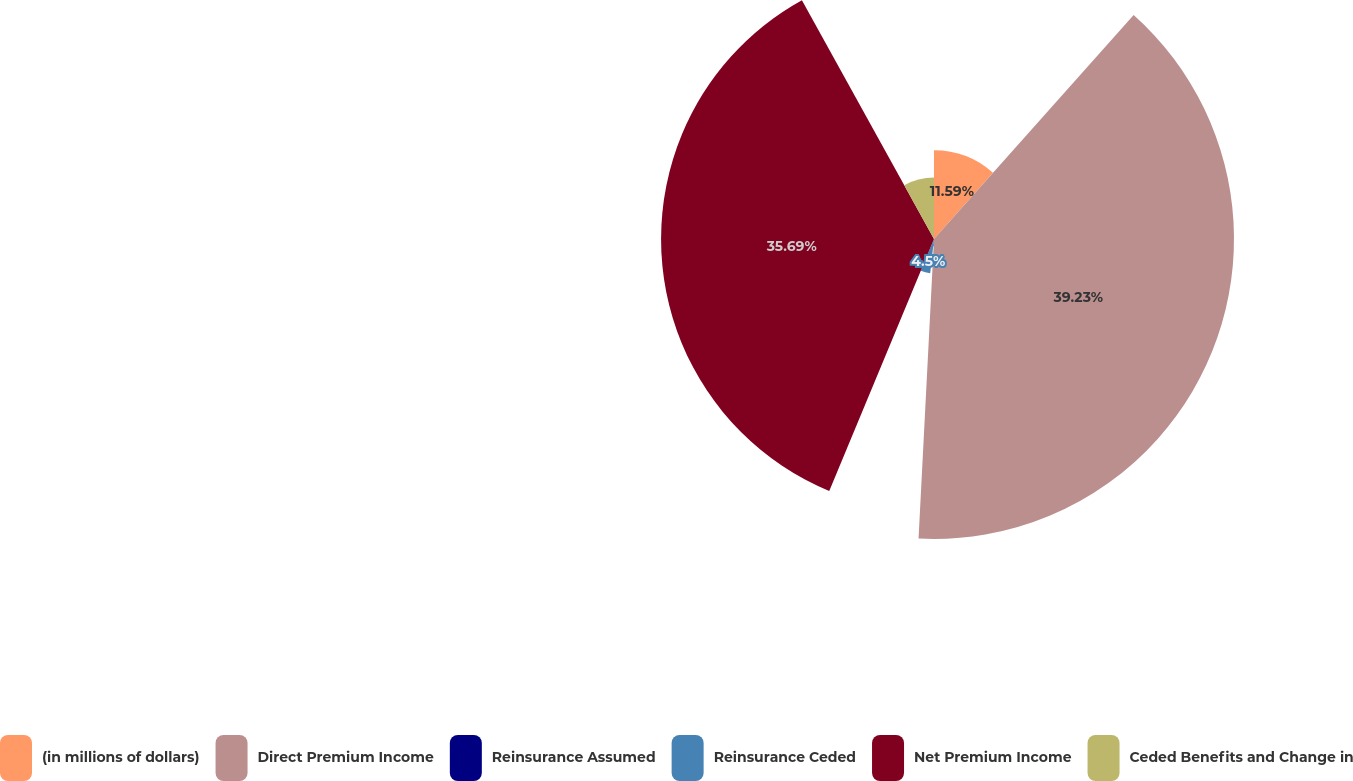Convert chart. <chart><loc_0><loc_0><loc_500><loc_500><pie_chart><fcel>(in millions of dollars)<fcel>Direct Premium Income<fcel>Reinsurance Assumed<fcel>Reinsurance Ceded<fcel>Net Premium Income<fcel>Ceded Benefits and Change in<nl><fcel>11.59%<fcel>39.23%<fcel>0.95%<fcel>4.5%<fcel>35.69%<fcel>8.04%<nl></chart> 